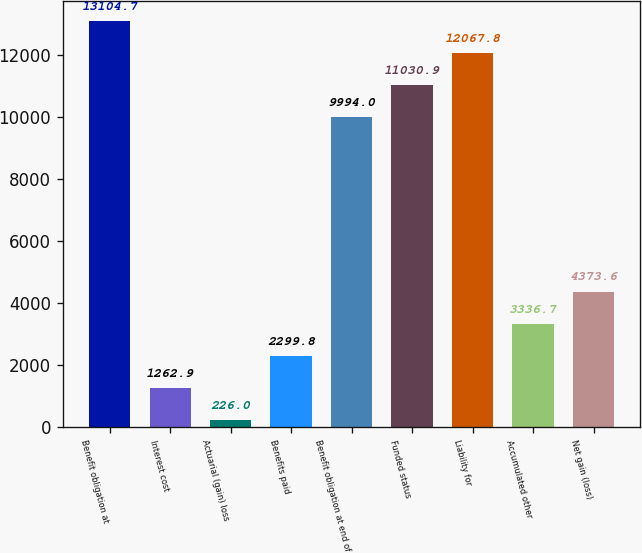Convert chart to OTSL. <chart><loc_0><loc_0><loc_500><loc_500><bar_chart><fcel>Benefit obligation at<fcel>Interest cost<fcel>Actuarial (gain) loss<fcel>Benefits paid<fcel>Benefit obligation at end of<fcel>Funded status<fcel>Liability for<fcel>Accumulated other<fcel>Net gain (loss)<nl><fcel>13104.7<fcel>1262.9<fcel>226<fcel>2299.8<fcel>9994<fcel>11030.9<fcel>12067.8<fcel>3336.7<fcel>4373.6<nl></chart> 